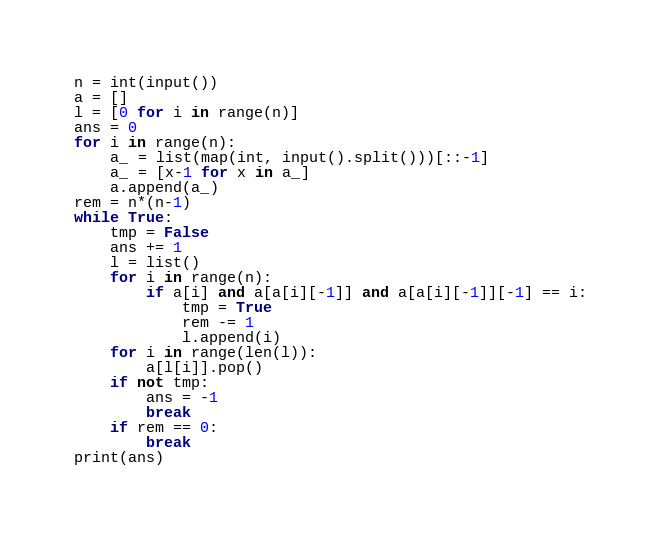Convert code to text. <code><loc_0><loc_0><loc_500><loc_500><_Python_>n = int(input())
a = []
l = [0 for i in range(n)]
ans = 0
for i in range(n):
    a_ = list(map(int, input().split()))[::-1]
    a_ = [x-1 for x in a_]
    a.append(a_)
rem = n*(n-1)
while True:
    tmp = False
    ans += 1
    l = list()
    for i in range(n):
        if a[i] and a[a[i][-1]] and a[a[i][-1]][-1] == i:
            tmp = True
            rem -= 1
            l.append(i)
    for i in range(len(l)):
        a[l[i]].pop()
    if not tmp:
        ans = -1
        break
    if rem == 0:
        break
print(ans)</code> 